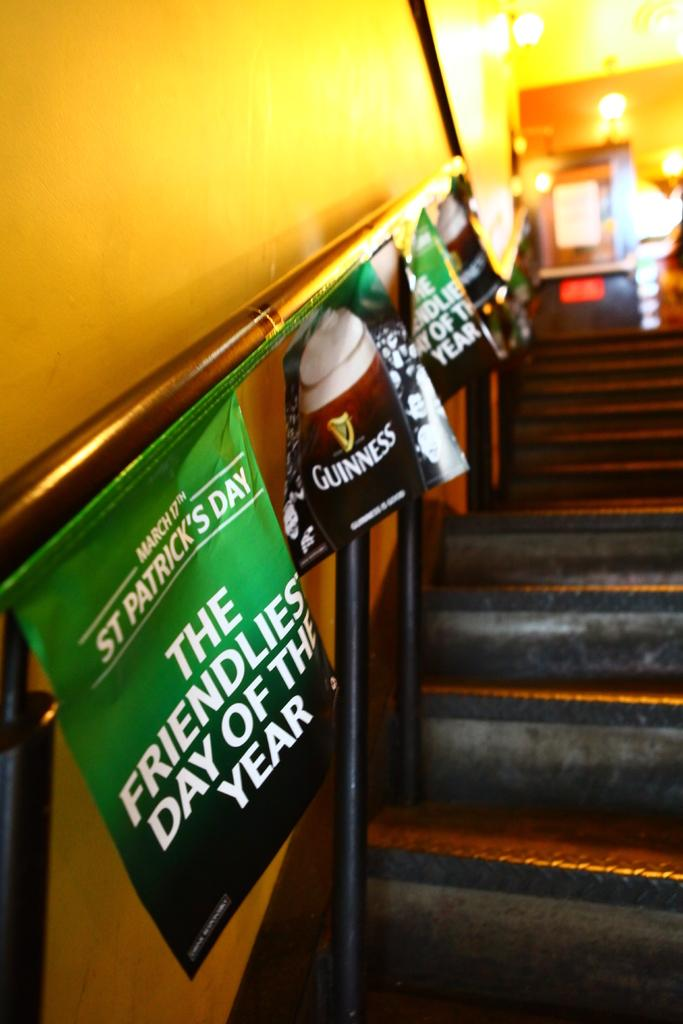Provide a one-sentence caption for the provided image. A staircase with banners for St. Patrick's Day and Guinness is shown. 